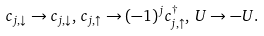Convert formula to latex. <formula><loc_0><loc_0><loc_500><loc_500>c _ { j , \downarrow } \rightarrow c _ { j , \downarrow } , \, c _ { j , \uparrow } \rightarrow ( - 1 ) ^ { j } c _ { j , \uparrow } ^ { \dagger } , \, U \rightarrow - U .</formula> 